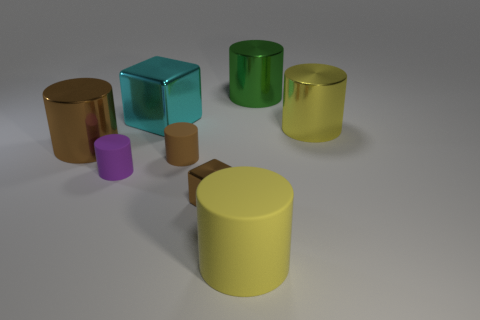Subtract all big brown metal cylinders. How many cylinders are left? 5 Subtract 1 cylinders. How many cylinders are left? 5 Subtract all brown cylinders. How many cylinders are left? 4 Add 1 big things. How many objects exist? 9 Subtract all blue blocks. Subtract all red cylinders. How many blocks are left? 2 Subtract all cylinders. How many objects are left? 2 Subtract 0 yellow blocks. How many objects are left? 8 Subtract all tiny brown cylinders. Subtract all brown matte cylinders. How many objects are left? 6 Add 6 large green objects. How many large green objects are left? 7 Add 5 green metallic cylinders. How many green metallic cylinders exist? 6 